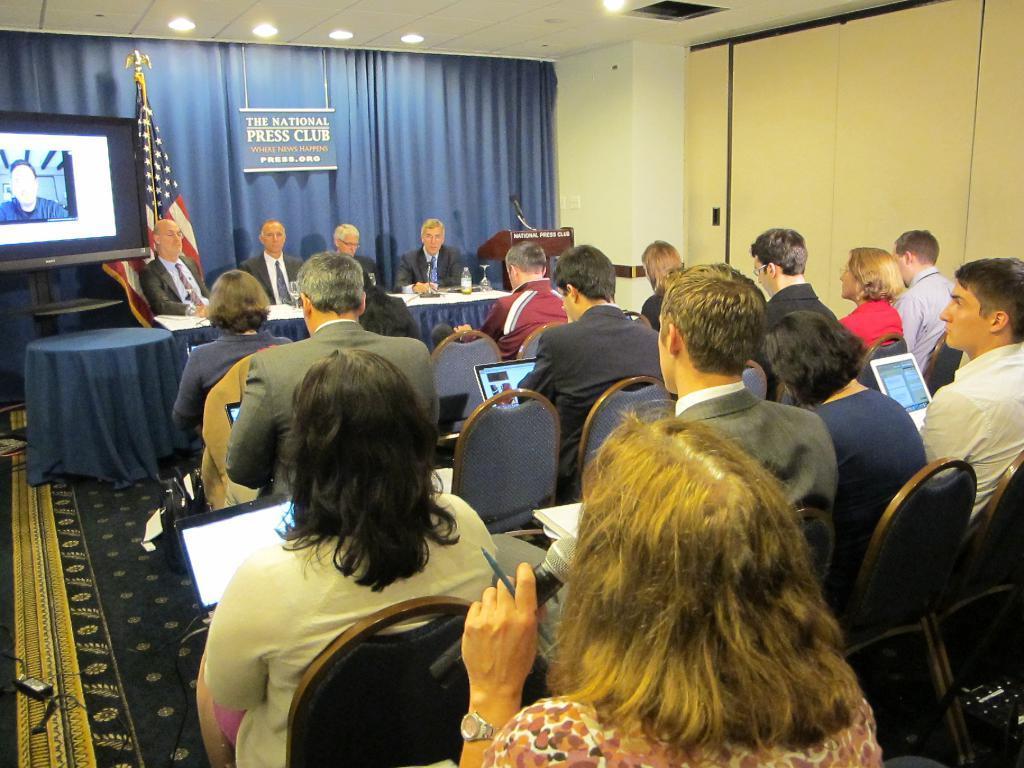Could you give a brief overview of what you see in this image? In this image we can see people are sitting on the chairs. Here we can see tables, clothes, flag, screen, curtain, board, ceiling, lights, laptop, bottle, glasses, wall, cable, podium, mike, and other objects. 